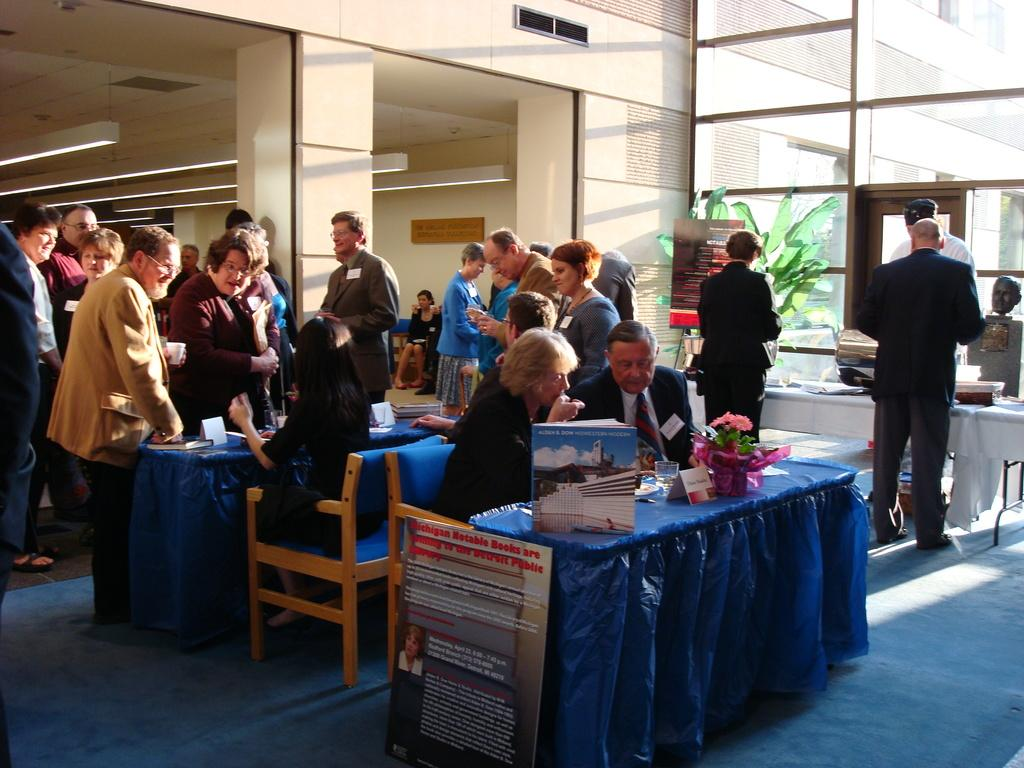What are the people in the image doing? There is a group of people sitting on chairs, and another group of people standing. What are the chairs in front of? The chairs are in front of tables. How many kittens are sitting on the chairs in the image? There are no kittens present in the image; it features people sitting on chairs and standing. 